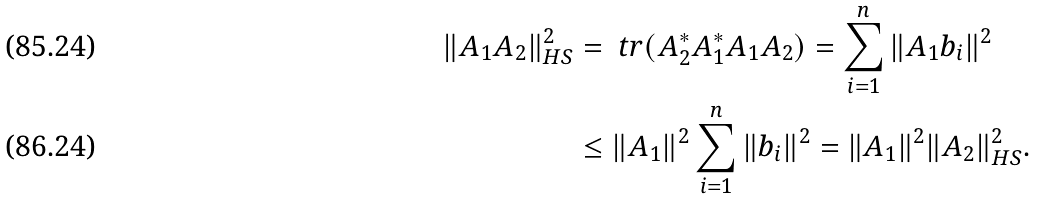<formula> <loc_0><loc_0><loc_500><loc_500>\| A _ { 1 } A _ { 2 } \| _ { H S } ^ { 2 } & = \ t r ( A _ { 2 } ^ { * } A _ { 1 } ^ { * } A _ { 1 } A _ { 2 } ) = \sum _ { i = 1 } ^ { n } \| A _ { 1 } b _ { i } \| ^ { 2 } \\ & \leq \| A _ { 1 } \| ^ { 2 } \sum _ { i = 1 } ^ { n } \| b _ { i } \| ^ { 2 } = \| A _ { 1 } \| ^ { 2 } \| A _ { 2 } \| ^ { 2 } _ { H S } .</formula> 